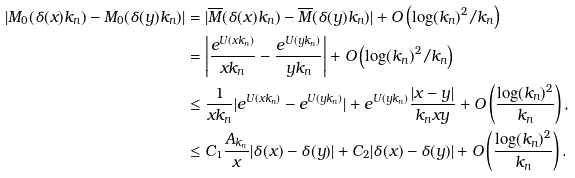<formula> <loc_0><loc_0><loc_500><loc_500>| M _ { 0 } ( \delta ( x ) k _ { n } ) - M _ { 0 } ( \delta ( y ) k _ { n } ) | & = | \overline { M } ( \delta ( x ) k _ { n } ) - \overline { M } ( \delta ( y ) k _ { n } ) | + O \left ( \log ( k _ { n } ) ^ { 2 } / k _ { n } \right ) \\ & = \left | \frac { e ^ { U ( x k _ { n } ) } } { x k _ { n } } - \frac { e ^ { U ( y k _ { n } ) } } { y k _ { n } } \right | + O \left ( \log ( k _ { n } ) ^ { 2 } / k _ { n } \right ) \\ & \leq \frac { 1 } { x k _ { n } } | e ^ { U ( x k _ { n } ) } - e ^ { U ( y k _ { n } ) } | + e ^ { U ( y k _ { n } ) } \frac { | x - y | } { k _ { n } x y } + O \left ( \frac { \log ( k _ { n } ) ^ { 2 } } { k _ { n } } \right ) , \\ & \leq C _ { 1 } \frac { A _ { k _ { n } } } { x } | \delta ( x ) - \delta ( y ) | + C _ { 2 } | \delta ( x ) - \delta ( y ) | + O \left ( \frac { \log ( k _ { n } ) ^ { 2 } } { k _ { n } } \right ) .</formula> 